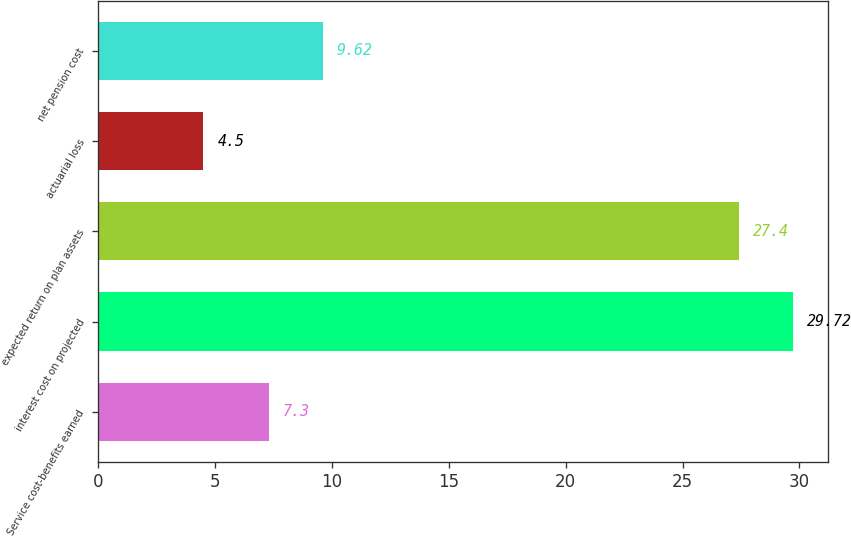Convert chart to OTSL. <chart><loc_0><loc_0><loc_500><loc_500><bar_chart><fcel>Service cost-benefits earned<fcel>interest cost on projected<fcel>expected return on plan assets<fcel>actuarial loss<fcel>net pension cost<nl><fcel>7.3<fcel>29.72<fcel>27.4<fcel>4.5<fcel>9.62<nl></chart> 